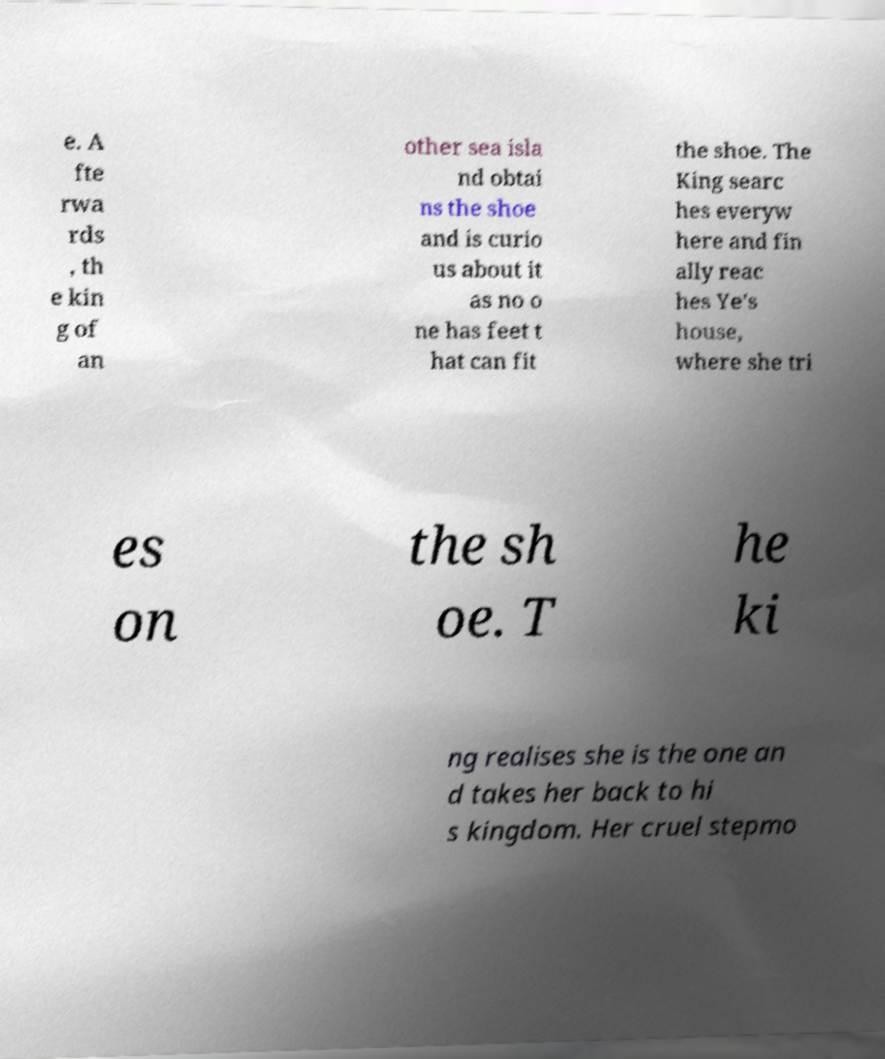For documentation purposes, I need the text within this image transcribed. Could you provide that? e. A fte rwa rds , th e kin g of an other sea isla nd obtai ns the shoe and is curio us about it as no o ne has feet t hat can fit the shoe. The King searc hes everyw here and fin ally reac hes Ye's house, where she tri es on the sh oe. T he ki ng realises she is the one an d takes her back to hi s kingdom. Her cruel stepmo 